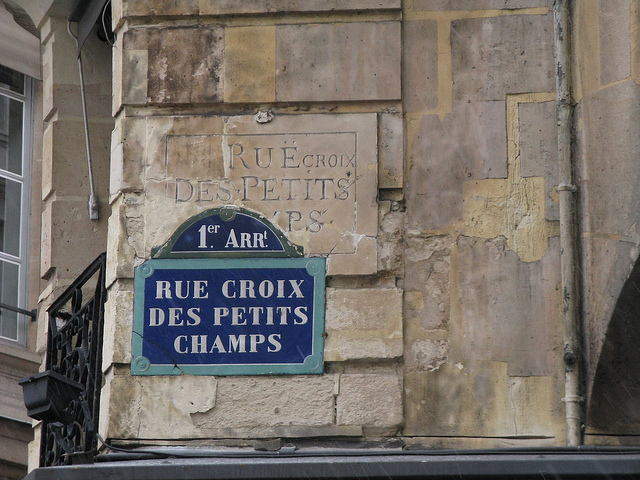<image>What does the street sign translate to in English? It is unknown what the street sign translates to in English, it could be 'little champ', 'cross street of small fields' or 'little champs'. What does the street sign translate to in English? It is unknown what does the street sign translate to in English. 